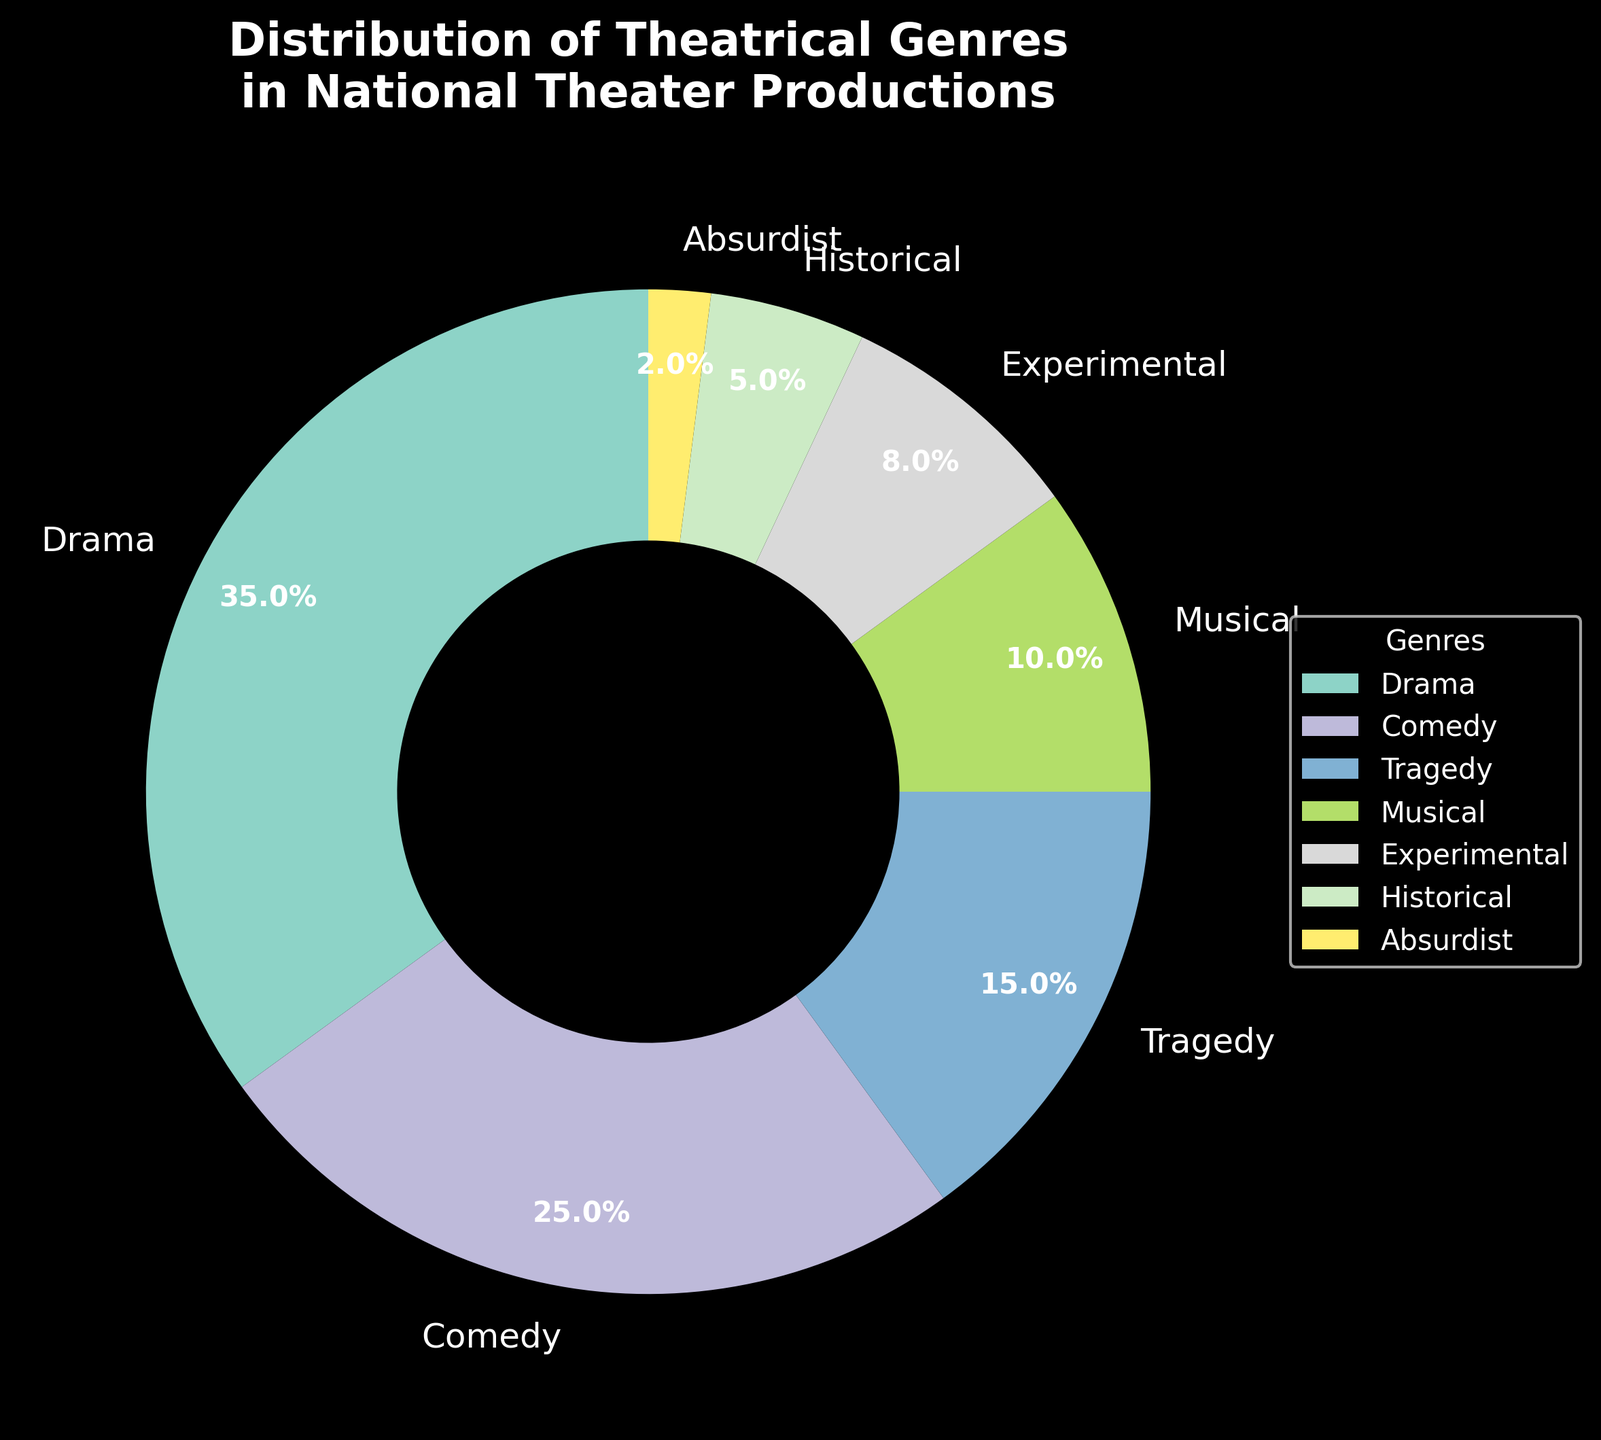What percentage of national theater productions are Dramas and Comedies combined? The chart shows that Dramas account for 35% and Comedies account for 25%. Adding these two percentages together, 35% + 25% = 60%.
Answer: 60% Which genre has a higher percentage, Historical or Musical? The chart shows that Historical accounts for 5%, while Musical accounts for 10%. Since 10% is greater than 5%, Musical has a higher percentage.
Answer: Musical What is the difference in percentage between the genre with the highest and the genre with the lowest representation? The genre with the highest percentage is Drama at 35%, and the genre with the lowest is Absurdist at 2%. The difference is 35% - 2% = 33%.
Answer: 33% How many genres have a percentage lower than 10%? To find out how many genres have a percentage lower than 10%, we look at the chart. Experimental (8%), Historical (5%), and Absurdist (2%) are below 10%. That's 3 genres.
Answer: 3 What is the average percentage of the Historical and Experimental genres? The chart shows Historical at 5% and Experimental at 8%. The average of these two percentages is (5% + 8%) / 2 = 6.5%.
Answer: 6.5% Which genre's segment is located adjacent to the starting position (90 degrees) in the pie chart? In the pie chart, the starting position (90 degrees) usually starts with the largest segment. Drama, being the largest segment at 35%, is likely to start at 90 degrees. The adjacent segment following clockwise would be Comedy at 25%.
Answer: Comedy Which genre has the second-largest representation, and what is its percentage? Drama has the largest at 35%. The next largest segment is Comedy at 25%.
Answer: Comedy, 25% What percentage of genres have a representation of 10% or more? The genres with 10% or more are Drama (35%), Comedy (25%), Tragedy (15%), and Musical (10%). That's 4 out of 7 total genres making the percentage (4/7) * 100 ≈ 57.1%.
Answer: 57.1% What is the combined percentage of Musical, Experimental, and Historical genres? The chart shows Musical at 10%, Experimental at 8%, and Historical at 5%. Adding these together, 10% + 8% + 5% = 23%.
Answer: 23% Compare the combined percentage of Tragedy and Absurdist genres to the percentage of Comedy. Which is higher? Tragedy accounts for 15% and Absurdist for 2%. Their combined percentage is 15% + 2% = 17%. The percentage for Comedy is 25%. Since 25% is greater than 17%, Comedy is higher.
Answer: Comedy 